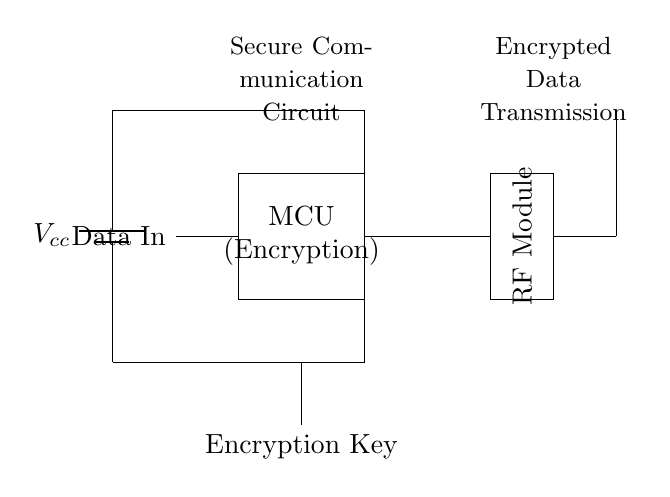What is the main component responsible for data encryption? The microcontroller (MCU) is designated for encryption, as noted in the label on the component within the circuit.
Answer: MCU What is the function of the RF module in this circuit? The RF module transmits the encrypted data wirelessly, indicated by its placement and connection to the antenna for communication purposes.
Answer: Transmit data What is the voltage supply type used in this circuit? The circuit shows a battery as the power source, which provides a DC voltage supply to the components.
Answer: Battery How is the encryption key provided to the circuit? The encryption key is shown entering from below the microcontroller, represented by the line connecting to the MCU with the label indicating it as an input.
Answer: Encryption Key Describe the relationship between the data input and the microcontroller. The data input is connected to the microcontroller, indicating that the MCU receives unencrypted data to process before encryption.
Answer: Data In What type of device does this circuit specifically facilitate? This circuit is designed for secure communication of sensitive data, emphasizing its application in transmitting encrypted fusion research data.
Answer: Secure communication device 